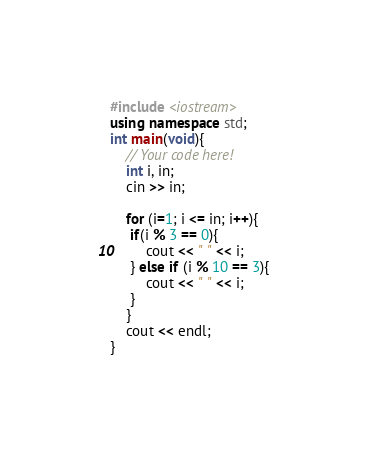<code> <loc_0><loc_0><loc_500><loc_500><_C++_>#include <iostream>
using namespace std;
int main(void){
    // Your code here!
    int i, in;
    cin >> in;
    
    for (i=1; i <= in; i++){
     if(i % 3 == 0){
         cout << " " << i;
     } else if (i % 10 == 3){
         cout << " " << i;
     }
    }
    cout << endl;
}

</code> 